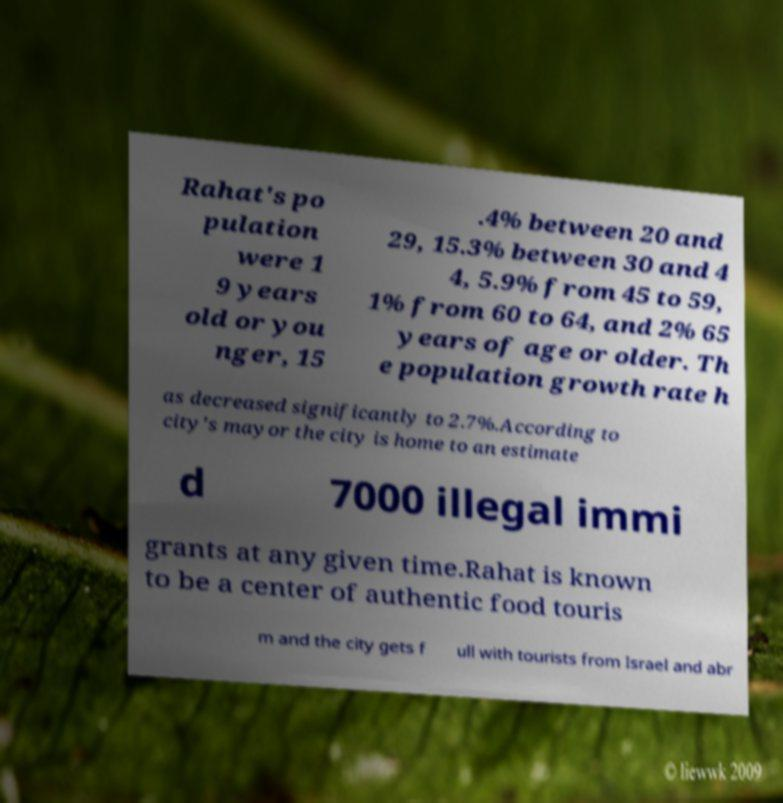Could you extract and type out the text from this image? Rahat's po pulation were 1 9 years old or you nger, 15 .4% between 20 and 29, 15.3% between 30 and 4 4, 5.9% from 45 to 59, 1% from 60 to 64, and 2% 65 years of age or older. Th e population growth rate h as decreased significantly to 2.7%.According to city's mayor the city is home to an estimate d 7000 illegal immi grants at any given time.Rahat is known to be a center of authentic food touris m and the city gets f ull with tourists from Israel and abr 